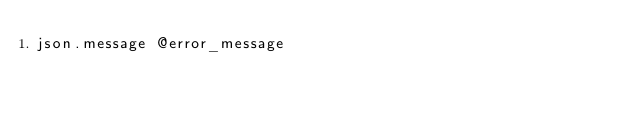<code> <loc_0><loc_0><loc_500><loc_500><_Ruby_>json.message @error_message
</code> 